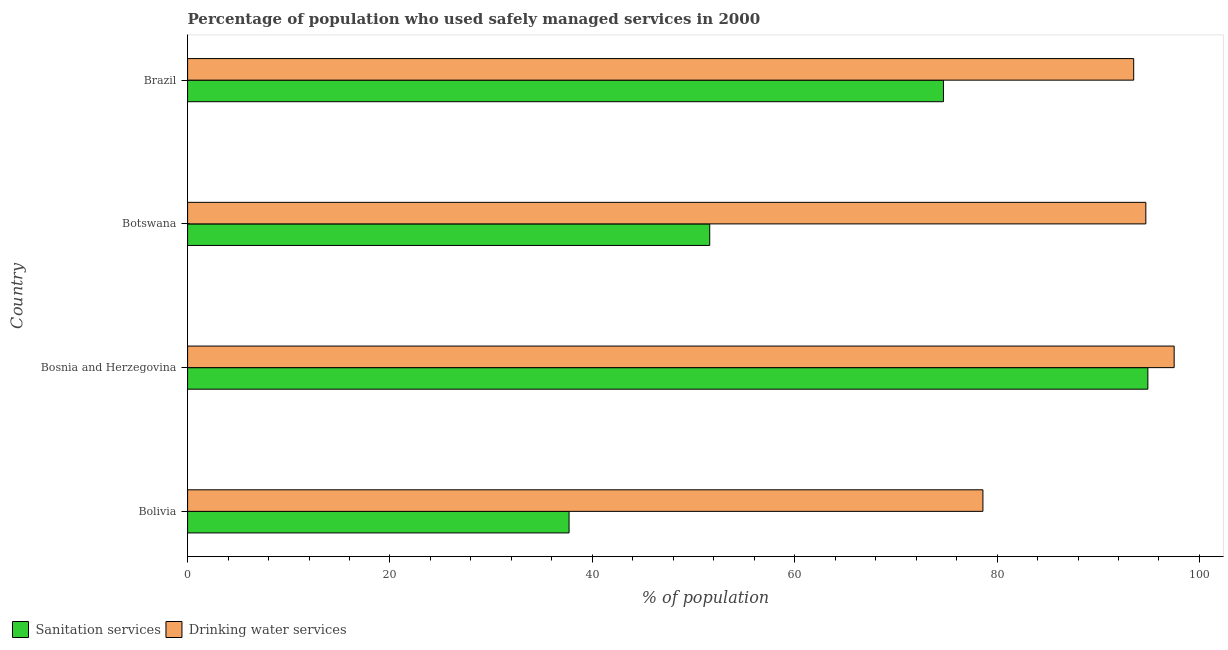How many different coloured bars are there?
Your answer should be very brief. 2. How many groups of bars are there?
Give a very brief answer. 4. Are the number of bars on each tick of the Y-axis equal?
Provide a short and direct response. Yes. How many bars are there on the 1st tick from the top?
Offer a very short reply. 2. In how many cases, is the number of bars for a given country not equal to the number of legend labels?
Your answer should be compact. 0. What is the percentage of population who used sanitation services in Bosnia and Herzegovina?
Your answer should be compact. 94.9. Across all countries, what is the maximum percentage of population who used drinking water services?
Make the answer very short. 97.5. Across all countries, what is the minimum percentage of population who used sanitation services?
Give a very brief answer. 37.7. In which country was the percentage of population who used drinking water services maximum?
Your answer should be compact. Bosnia and Herzegovina. In which country was the percentage of population who used drinking water services minimum?
Ensure brevity in your answer.  Bolivia. What is the total percentage of population who used drinking water services in the graph?
Give a very brief answer. 364.3. What is the average percentage of population who used drinking water services per country?
Offer a very short reply. 91.08. What is the difference between the percentage of population who used drinking water services and percentage of population who used sanitation services in Bolivia?
Your answer should be compact. 40.9. In how many countries, is the percentage of population who used sanitation services greater than 32 %?
Offer a terse response. 4. What is the ratio of the percentage of population who used sanitation services in Bolivia to that in Brazil?
Provide a short and direct response. 0.51. Is the difference between the percentage of population who used drinking water services in Bolivia and Brazil greater than the difference between the percentage of population who used sanitation services in Bolivia and Brazil?
Offer a very short reply. Yes. What is the difference between the highest and the lowest percentage of population who used drinking water services?
Give a very brief answer. 18.9. In how many countries, is the percentage of population who used sanitation services greater than the average percentage of population who used sanitation services taken over all countries?
Offer a terse response. 2. What does the 1st bar from the top in Bolivia represents?
Make the answer very short. Drinking water services. What does the 2nd bar from the bottom in Bosnia and Herzegovina represents?
Provide a short and direct response. Drinking water services. How many bars are there?
Provide a succinct answer. 8. How many countries are there in the graph?
Make the answer very short. 4. What is the difference between two consecutive major ticks on the X-axis?
Offer a terse response. 20. Where does the legend appear in the graph?
Ensure brevity in your answer.  Bottom left. How are the legend labels stacked?
Provide a succinct answer. Horizontal. What is the title of the graph?
Give a very brief answer. Percentage of population who used safely managed services in 2000. Does "Register a business" appear as one of the legend labels in the graph?
Offer a very short reply. No. What is the label or title of the X-axis?
Offer a very short reply. % of population. What is the % of population of Sanitation services in Bolivia?
Offer a terse response. 37.7. What is the % of population of Drinking water services in Bolivia?
Make the answer very short. 78.6. What is the % of population of Sanitation services in Bosnia and Herzegovina?
Your answer should be compact. 94.9. What is the % of population in Drinking water services in Bosnia and Herzegovina?
Keep it short and to the point. 97.5. What is the % of population of Sanitation services in Botswana?
Offer a very short reply. 51.6. What is the % of population of Drinking water services in Botswana?
Offer a very short reply. 94.7. What is the % of population in Sanitation services in Brazil?
Your answer should be very brief. 74.7. What is the % of population in Drinking water services in Brazil?
Ensure brevity in your answer.  93.5. Across all countries, what is the maximum % of population in Sanitation services?
Offer a terse response. 94.9. Across all countries, what is the maximum % of population of Drinking water services?
Provide a short and direct response. 97.5. Across all countries, what is the minimum % of population in Sanitation services?
Offer a very short reply. 37.7. Across all countries, what is the minimum % of population in Drinking water services?
Your answer should be compact. 78.6. What is the total % of population in Sanitation services in the graph?
Ensure brevity in your answer.  258.9. What is the total % of population of Drinking water services in the graph?
Keep it short and to the point. 364.3. What is the difference between the % of population in Sanitation services in Bolivia and that in Bosnia and Herzegovina?
Your response must be concise. -57.2. What is the difference between the % of population of Drinking water services in Bolivia and that in Bosnia and Herzegovina?
Keep it short and to the point. -18.9. What is the difference between the % of population in Sanitation services in Bolivia and that in Botswana?
Keep it short and to the point. -13.9. What is the difference between the % of population in Drinking water services in Bolivia and that in Botswana?
Offer a very short reply. -16.1. What is the difference between the % of population of Sanitation services in Bolivia and that in Brazil?
Give a very brief answer. -37. What is the difference between the % of population of Drinking water services in Bolivia and that in Brazil?
Keep it short and to the point. -14.9. What is the difference between the % of population in Sanitation services in Bosnia and Herzegovina and that in Botswana?
Make the answer very short. 43.3. What is the difference between the % of population in Sanitation services in Bosnia and Herzegovina and that in Brazil?
Offer a terse response. 20.2. What is the difference between the % of population of Drinking water services in Bosnia and Herzegovina and that in Brazil?
Offer a terse response. 4. What is the difference between the % of population of Sanitation services in Botswana and that in Brazil?
Your answer should be compact. -23.1. What is the difference between the % of population of Sanitation services in Bolivia and the % of population of Drinking water services in Bosnia and Herzegovina?
Give a very brief answer. -59.8. What is the difference between the % of population of Sanitation services in Bolivia and the % of population of Drinking water services in Botswana?
Give a very brief answer. -57. What is the difference between the % of population of Sanitation services in Bolivia and the % of population of Drinking water services in Brazil?
Give a very brief answer. -55.8. What is the difference between the % of population of Sanitation services in Botswana and the % of population of Drinking water services in Brazil?
Ensure brevity in your answer.  -41.9. What is the average % of population of Sanitation services per country?
Keep it short and to the point. 64.72. What is the average % of population of Drinking water services per country?
Your answer should be compact. 91.08. What is the difference between the % of population in Sanitation services and % of population in Drinking water services in Bolivia?
Provide a succinct answer. -40.9. What is the difference between the % of population in Sanitation services and % of population in Drinking water services in Botswana?
Provide a short and direct response. -43.1. What is the difference between the % of population of Sanitation services and % of population of Drinking water services in Brazil?
Give a very brief answer. -18.8. What is the ratio of the % of population in Sanitation services in Bolivia to that in Bosnia and Herzegovina?
Make the answer very short. 0.4. What is the ratio of the % of population in Drinking water services in Bolivia to that in Bosnia and Herzegovina?
Offer a very short reply. 0.81. What is the ratio of the % of population in Sanitation services in Bolivia to that in Botswana?
Your response must be concise. 0.73. What is the ratio of the % of population in Drinking water services in Bolivia to that in Botswana?
Provide a succinct answer. 0.83. What is the ratio of the % of population in Sanitation services in Bolivia to that in Brazil?
Your response must be concise. 0.5. What is the ratio of the % of population of Drinking water services in Bolivia to that in Brazil?
Your response must be concise. 0.84. What is the ratio of the % of population of Sanitation services in Bosnia and Herzegovina to that in Botswana?
Ensure brevity in your answer.  1.84. What is the ratio of the % of population in Drinking water services in Bosnia and Herzegovina to that in Botswana?
Give a very brief answer. 1.03. What is the ratio of the % of population in Sanitation services in Bosnia and Herzegovina to that in Brazil?
Offer a very short reply. 1.27. What is the ratio of the % of population in Drinking water services in Bosnia and Herzegovina to that in Brazil?
Ensure brevity in your answer.  1.04. What is the ratio of the % of population of Sanitation services in Botswana to that in Brazil?
Provide a short and direct response. 0.69. What is the ratio of the % of population in Drinking water services in Botswana to that in Brazil?
Ensure brevity in your answer.  1.01. What is the difference between the highest and the second highest % of population in Sanitation services?
Ensure brevity in your answer.  20.2. What is the difference between the highest and the second highest % of population in Drinking water services?
Ensure brevity in your answer.  2.8. What is the difference between the highest and the lowest % of population of Sanitation services?
Your response must be concise. 57.2. 